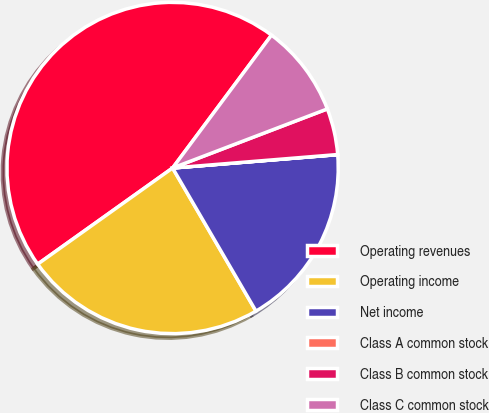<chart> <loc_0><loc_0><loc_500><loc_500><pie_chart><fcel>Operating revenues<fcel>Operating income<fcel>Net income<fcel>Class A common stock<fcel>Class B common stock<fcel>Class C common stock<nl><fcel>45.04%<fcel>23.54%<fcel>17.89%<fcel>0.01%<fcel>4.51%<fcel>9.01%<nl></chart> 